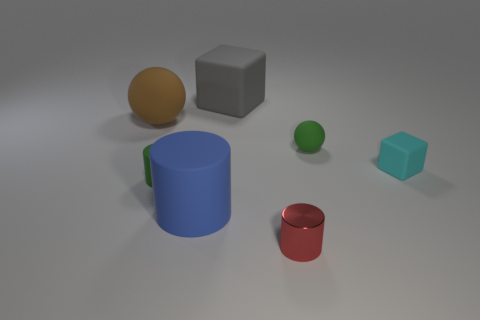Subtract all rubber cylinders. How many cylinders are left? 1 Subtract all blocks. How many objects are left? 5 Subtract all blue cylinders. How many cylinders are left? 2 Subtract all purple cylinders. Subtract all gray blocks. How many cylinders are left? 3 Subtract all green spheres. How many red cylinders are left? 1 Subtract all gray metal balls. Subtract all cyan rubber things. How many objects are left? 6 Add 7 large things. How many large things are left? 10 Add 1 green rubber cylinders. How many green rubber cylinders exist? 2 Add 3 cyan rubber blocks. How many objects exist? 10 Subtract 0 purple balls. How many objects are left? 7 